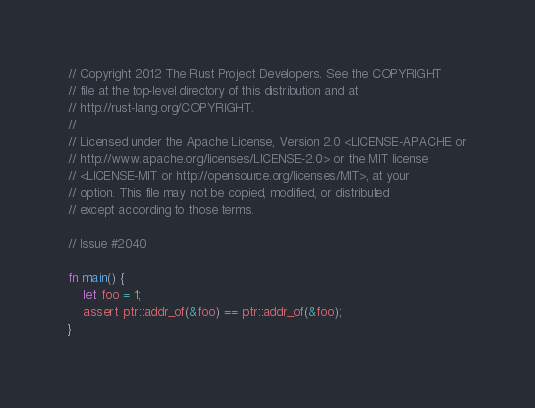Convert code to text. <code><loc_0><loc_0><loc_500><loc_500><_Rust_>// Copyright 2012 The Rust Project Developers. See the COPYRIGHT
// file at the top-level directory of this distribution and at
// http://rust-lang.org/COPYRIGHT.
//
// Licensed under the Apache License, Version 2.0 <LICENSE-APACHE or
// http://www.apache.org/licenses/LICENSE-2.0> or the MIT license
// <LICENSE-MIT or http://opensource.org/licenses/MIT>, at your
// option. This file may not be copied, modified, or distributed
// except according to those terms.

// Issue #2040

fn main() {
    let foo = 1;
    assert ptr::addr_of(&foo) == ptr::addr_of(&foo);
}
</code> 